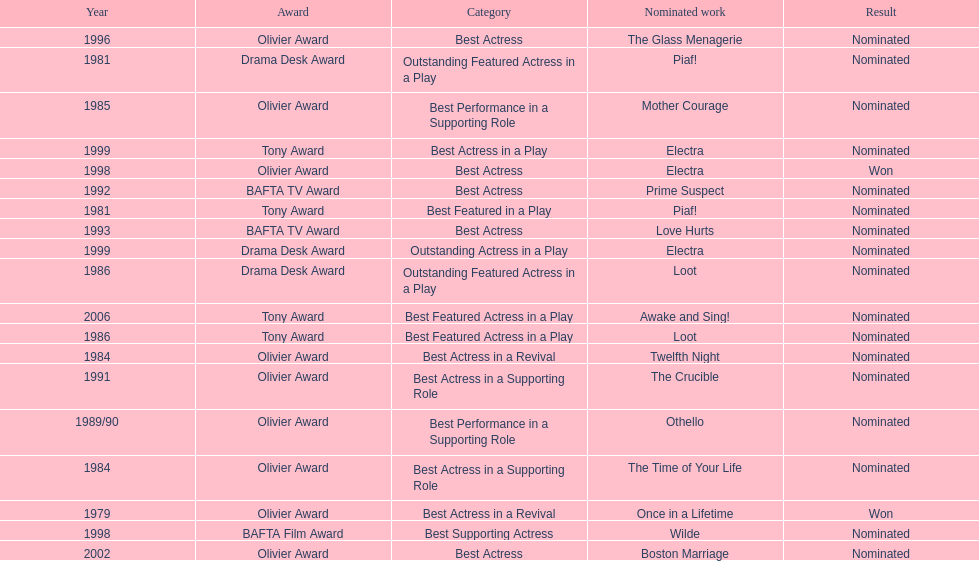What play was wanamaker nominated for best featured in a play in 1981? Piaf!. 